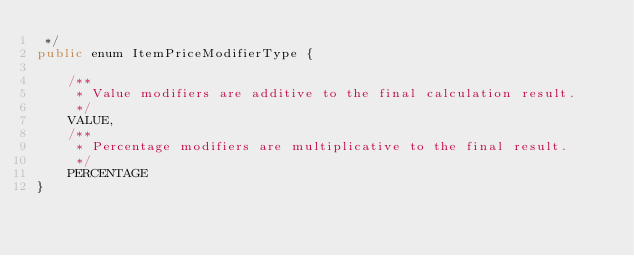Convert code to text. <code><loc_0><loc_0><loc_500><loc_500><_Java_> */
public enum ItemPriceModifierType {

    /**
     * Value modifiers are additive to the final calculation result.
     */
    VALUE,
    /**
     * Percentage modifiers are multiplicative to the final result.
     */
    PERCENTAGE
}
</code> 